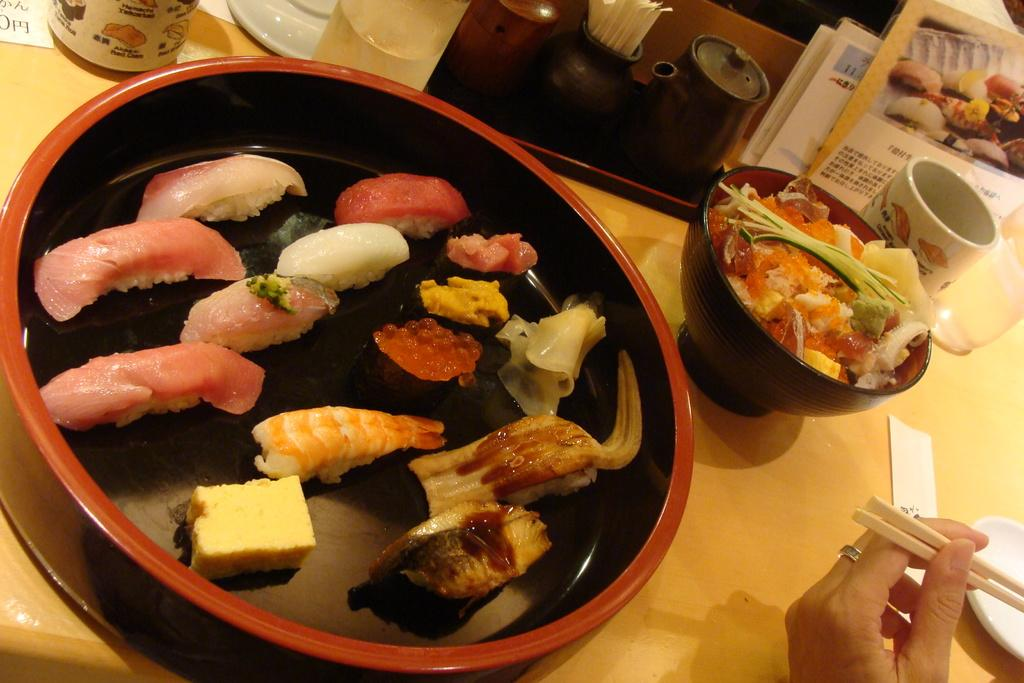What type of food items can be seen in the image? There are different food items in the image. How are the food items arranged in the image? The food items are placed in a bowl. Where is the bowl located in the image? The bowl is on a table. What is being used to eat the food in the image? There is a hand with chopsticks in the image. What else can be seen on the table besides the bowl of food? There are books and a cup in the image. How does the friction between the chopsticks and the food affect the eating process in the image? There is no mention of friction between the chopsticks and the food in the image, and therefore it cannot be determined how it affects the eating process. 